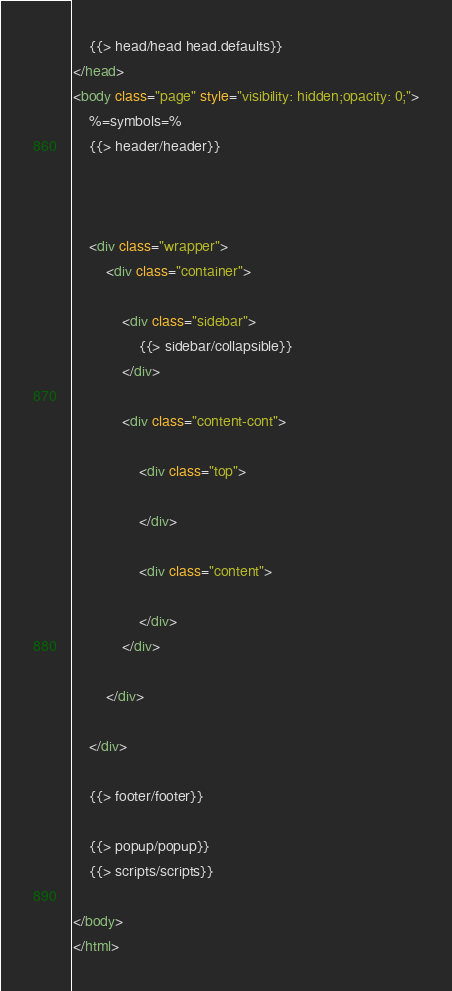Convert code to text. <code><loc_0><loc_0><loc_500><loc_500><_HTML_>    {{> head/head head.defaults}}
</head>
<body class="page" style="visibility: hidden;opacity: 0;">
    %=symbols=%
    {{> header/header}}

    
    
    <div class="wrapper">
        <div class="container">
            
            <div class="sidebar">
                {{> sidebar/collapsible}}
            </div>

            <div class="content-cont">

                <div class="top">
                   
                </div>
                
                <div class="content">
                    
                </div>
            </div>

        </div>
        
    </div>

    {{> footer/footer}}
   
    {{> popup/popup}}
    {{> scripts/scripts}}
    
</body>
</html></code> 